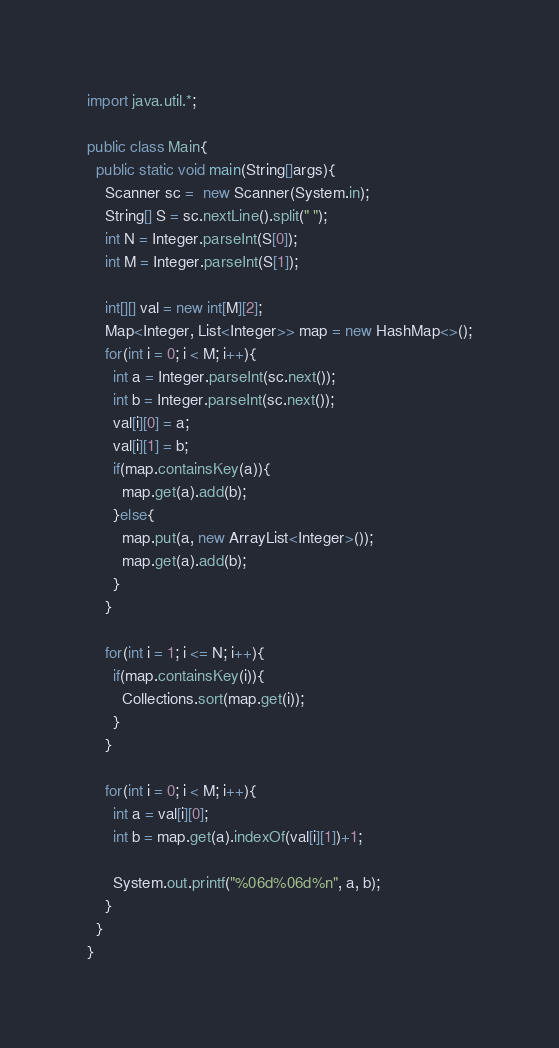Convert code to text. <code><loc_0><loc_0><loc_500><loc_500><_Java_>import java.util.*;
 
public class Main{
  public static void main(String[]args){
    Scanner sc =  new Scanner(System.in);
    String[] S = sc.nextLine().split(" ");
    int N = Integer.parseInt(S[0]);
    int M = Integer.parseInt(S[1]);
    
    int[][] val = new int[M][2];
    Map<Integer, List<Integer>> map = new HashMap<>();
    for(int i = 0; i < M; i++){
      int a = Integer.parseInt(sc.next());
      int b = Integer.parseInt(sc.next());
      val[i][0] = a;
      val[i][1] = b;
      if(map.containsKey(a)){
        map.get(a).add(b);
      }else{
        map.put(a, new ArrayList<Integer>());
        map.get(a).add(b);
      }
    }
    
    for(int i = 1; i <= N; i++){
      if(map.containsKey(i)){
        Collections.sort(map.get(i));
      }
    }
    
    for(int i = 0; i < M; i++){
      int a = val[i][0];
      int b = map.get(a).indexOf(val[i][1])+1;
      
      System.out.printf("%06d%06d%n", a, b);
    }
  }
}</code> 